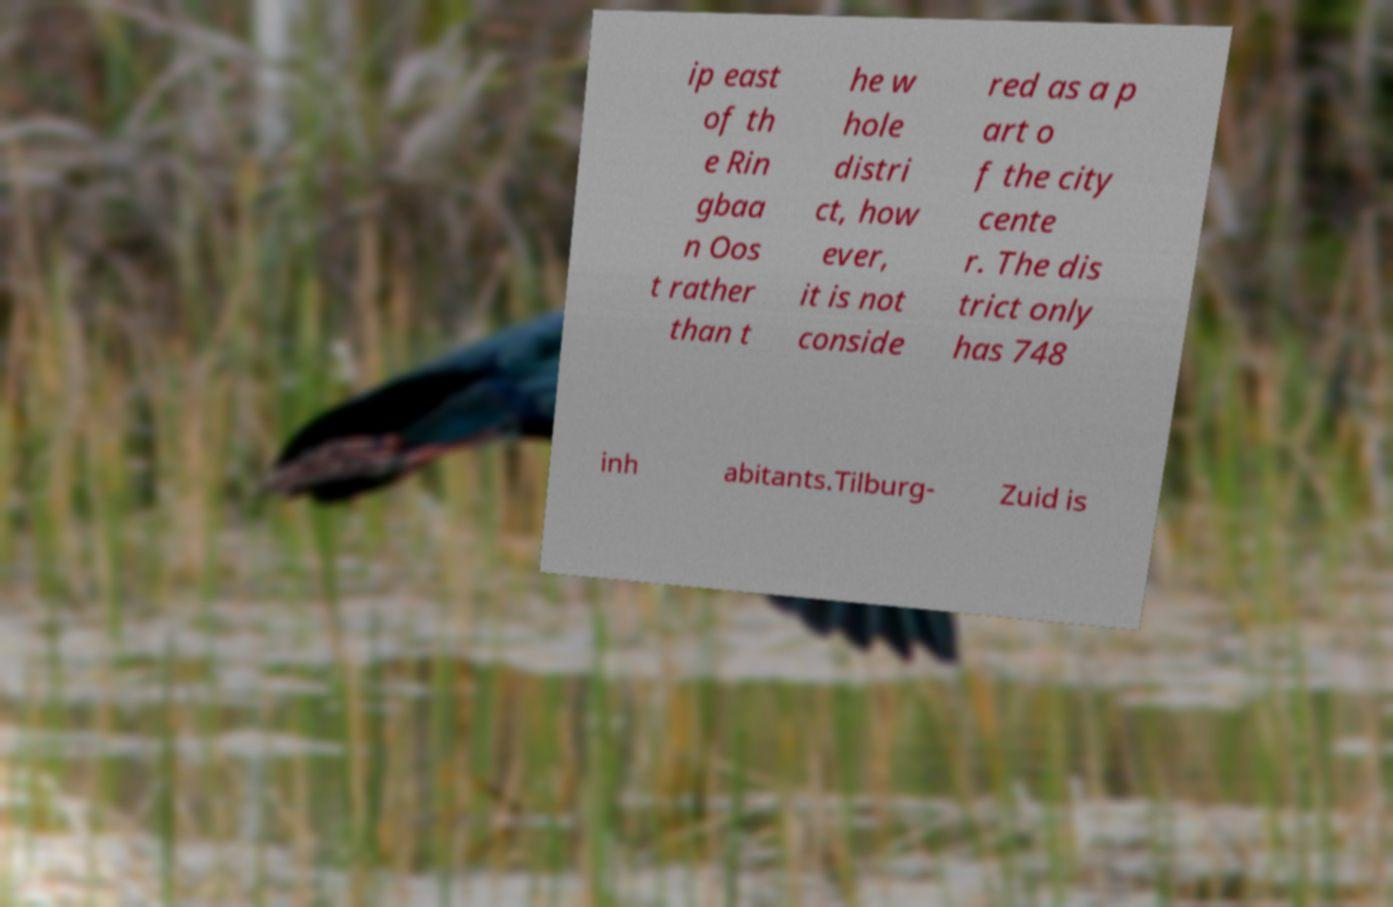Can you accurately transcribe the text from the provided image for me? ip east of th e Rin gbaa n Oos t rather than t he w hole distri ct, how ever, it is not conside red as a p art o f the city cente r. The dis trict only has 748 inh abitants.Tilburg- Zuid is 